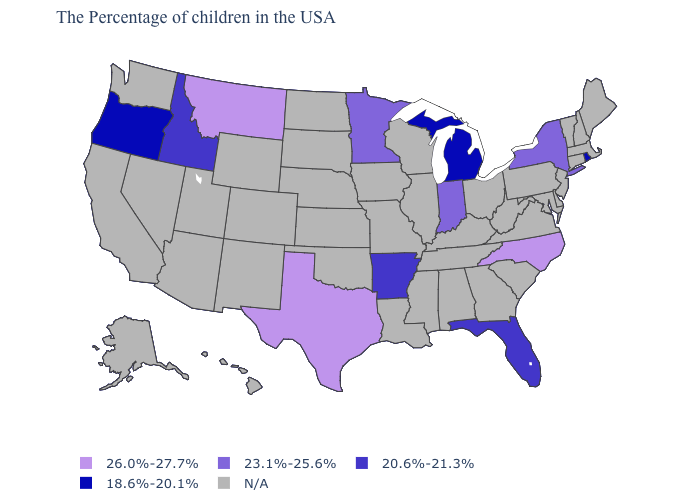How many symbols are there in the legend?
Be succinct. 5. Which states have the lowest value in the USA?
Answer briefly. Rhode Island, Michigan, Oregon. Name the states that have a value in the range 18.6%-20.1%?
Be succinct. Rhode Island, Michigan, Oregon. Name the states that have a value in the range N/A?
Quick response, please. Maine, Massachusetts, New Hampshire, Vermont, Connecticut, New Jersey, Delaware, Maryland, Pennsylvania, Virginia, South Carolina, West Virginia, Ohio, Georgia, Kentucky, Alabama, Tennessee, Wisconsin, Illinois, Mississippi, Louisiana, Missouri, Iowa, Kansas, Nebraska, Oklahoma, South Dakota, North Dakota, Wyoming, Colorado, New Mexico, Utah, Arizona, Nevada, California, Washington, Alaska, Hawaii. Name the states that have a value in the range 23.1%-25.6%?
Keep it brief. New York, Indiana, Minnesota. What is the lowest value in states that border Nevada?
Short answer required. 18.6%-20.1%. What is the value of Ohio?
Quick response, please. N/A. Does Rhode Island have the lowest value in the Northeast?
Concise answer only. Yes. What is the lowest value in states that border Utah?
Short answer required. 20.6%-21.3%. What is the highest value in the USA?
Give a very brief answer. 26.0%-27.7%. 